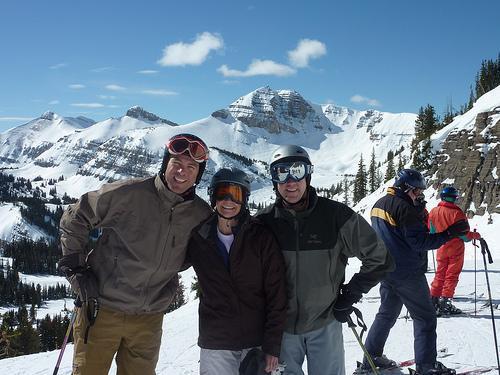How many people are facing the camera?
Give a very brief answer. 3. How many women are facing the camera?
Give a very brief answer. 1. How many people have ski glasses over their eyes?
Give a very brief answer. 2. How many people are in the background?
Give a very brief answer. 2. How many skiers are wearing goggles over their eyes?
Give a very brief answer. 3. 